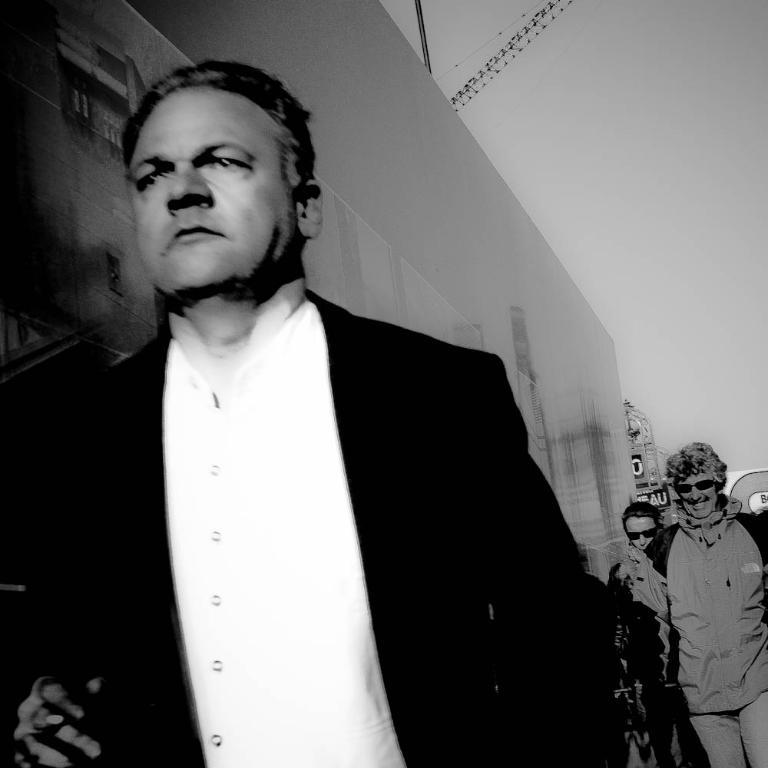What is the color scheme of the image? The image is black and white. What can be seen at the bottom of the image? There are people at the bottom of the image. What is located in the background of the image? There is a wall in the background of the image. What is visible at the top of the image? The sky is visible at the top of the image. What type of farm animals can be seen participating in the protest in the image? There is no farm or protest depicted in the image; it features people and a wall in a black and white setting. 